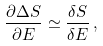Convert formula to latex. <formula><loc_0><loc_0><loc_500><loc_500>\frac { \partial \Delta S } { \partial E } \simeq \frac { \delta S } { \delta E } \, ,</formula> 